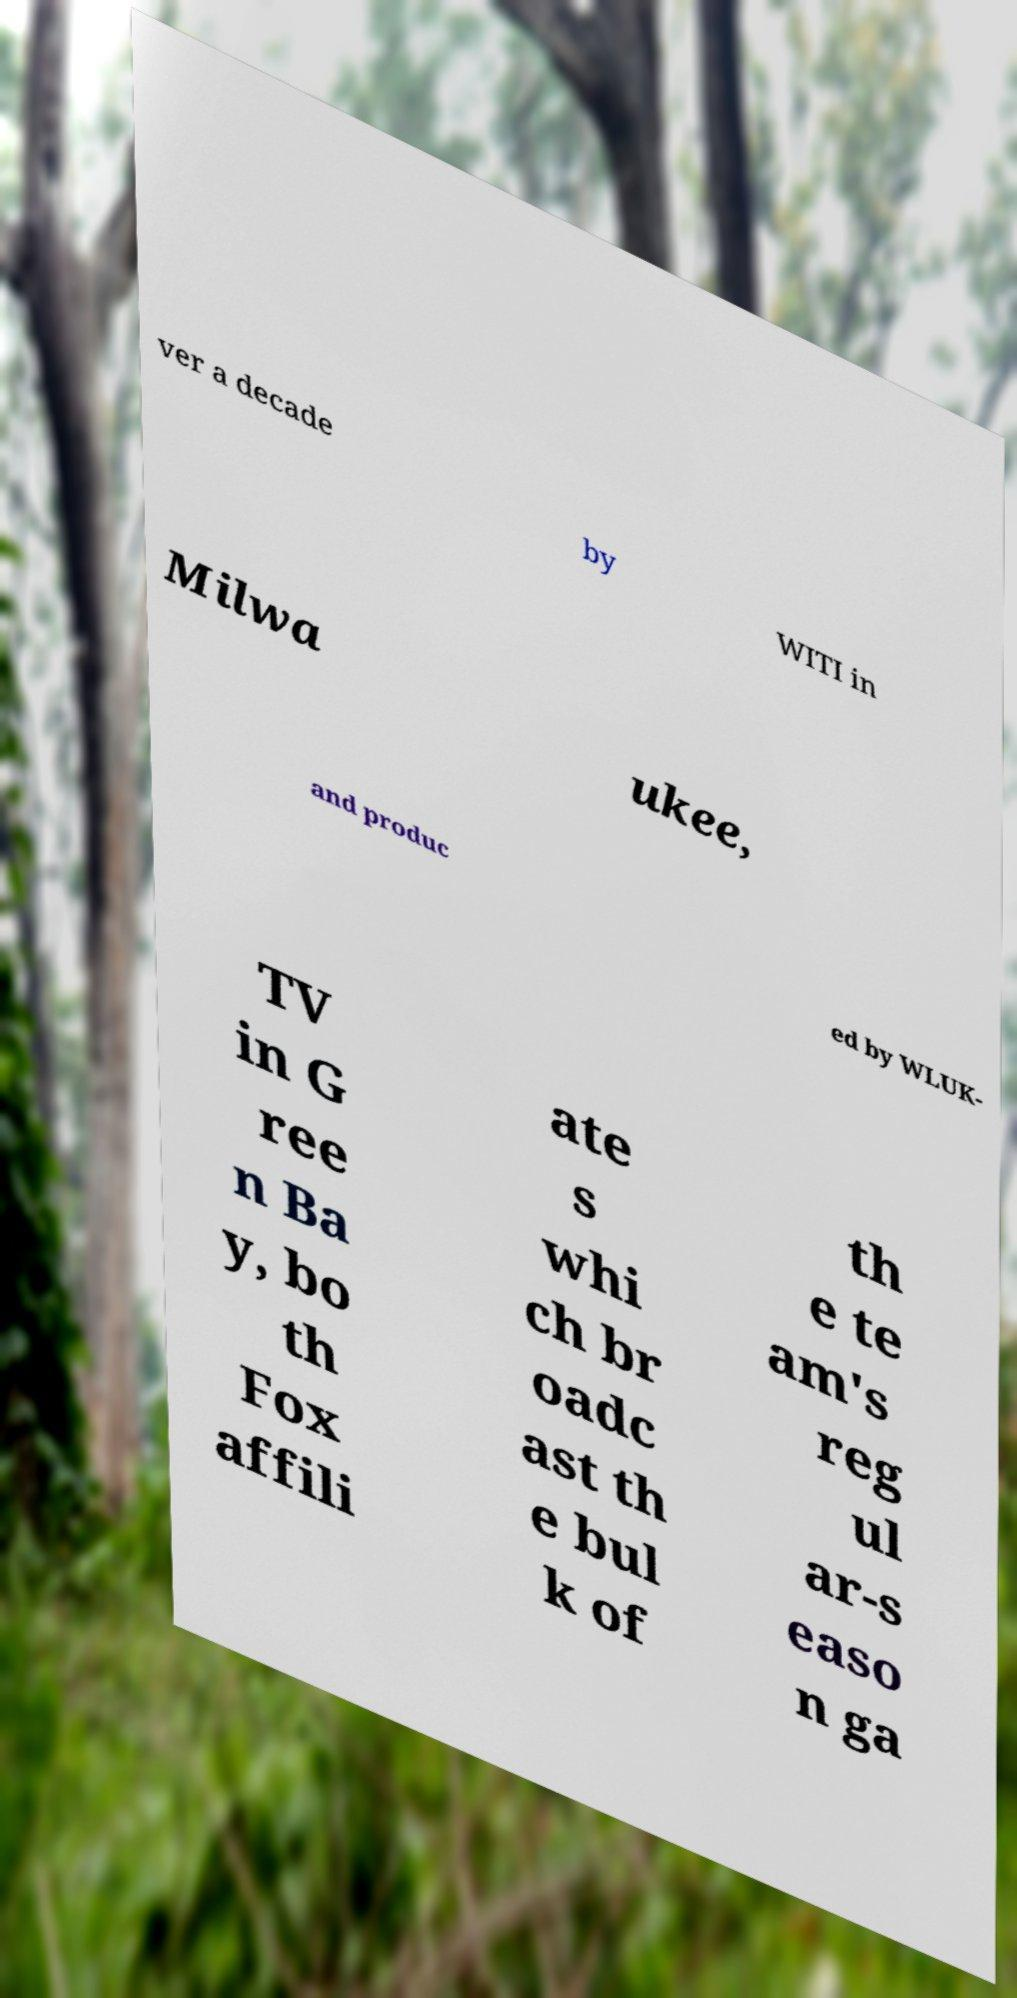I need the written content from this picture converted into text. Can you do that? ver a decade by WITI in Milwa ukee, and produc ed by WLUK- TV in G ree n Ba y, bo th Fox affili ate s whi ch br oadc ast th e bul k of th e te am's reg ul ar-s easo n ga 